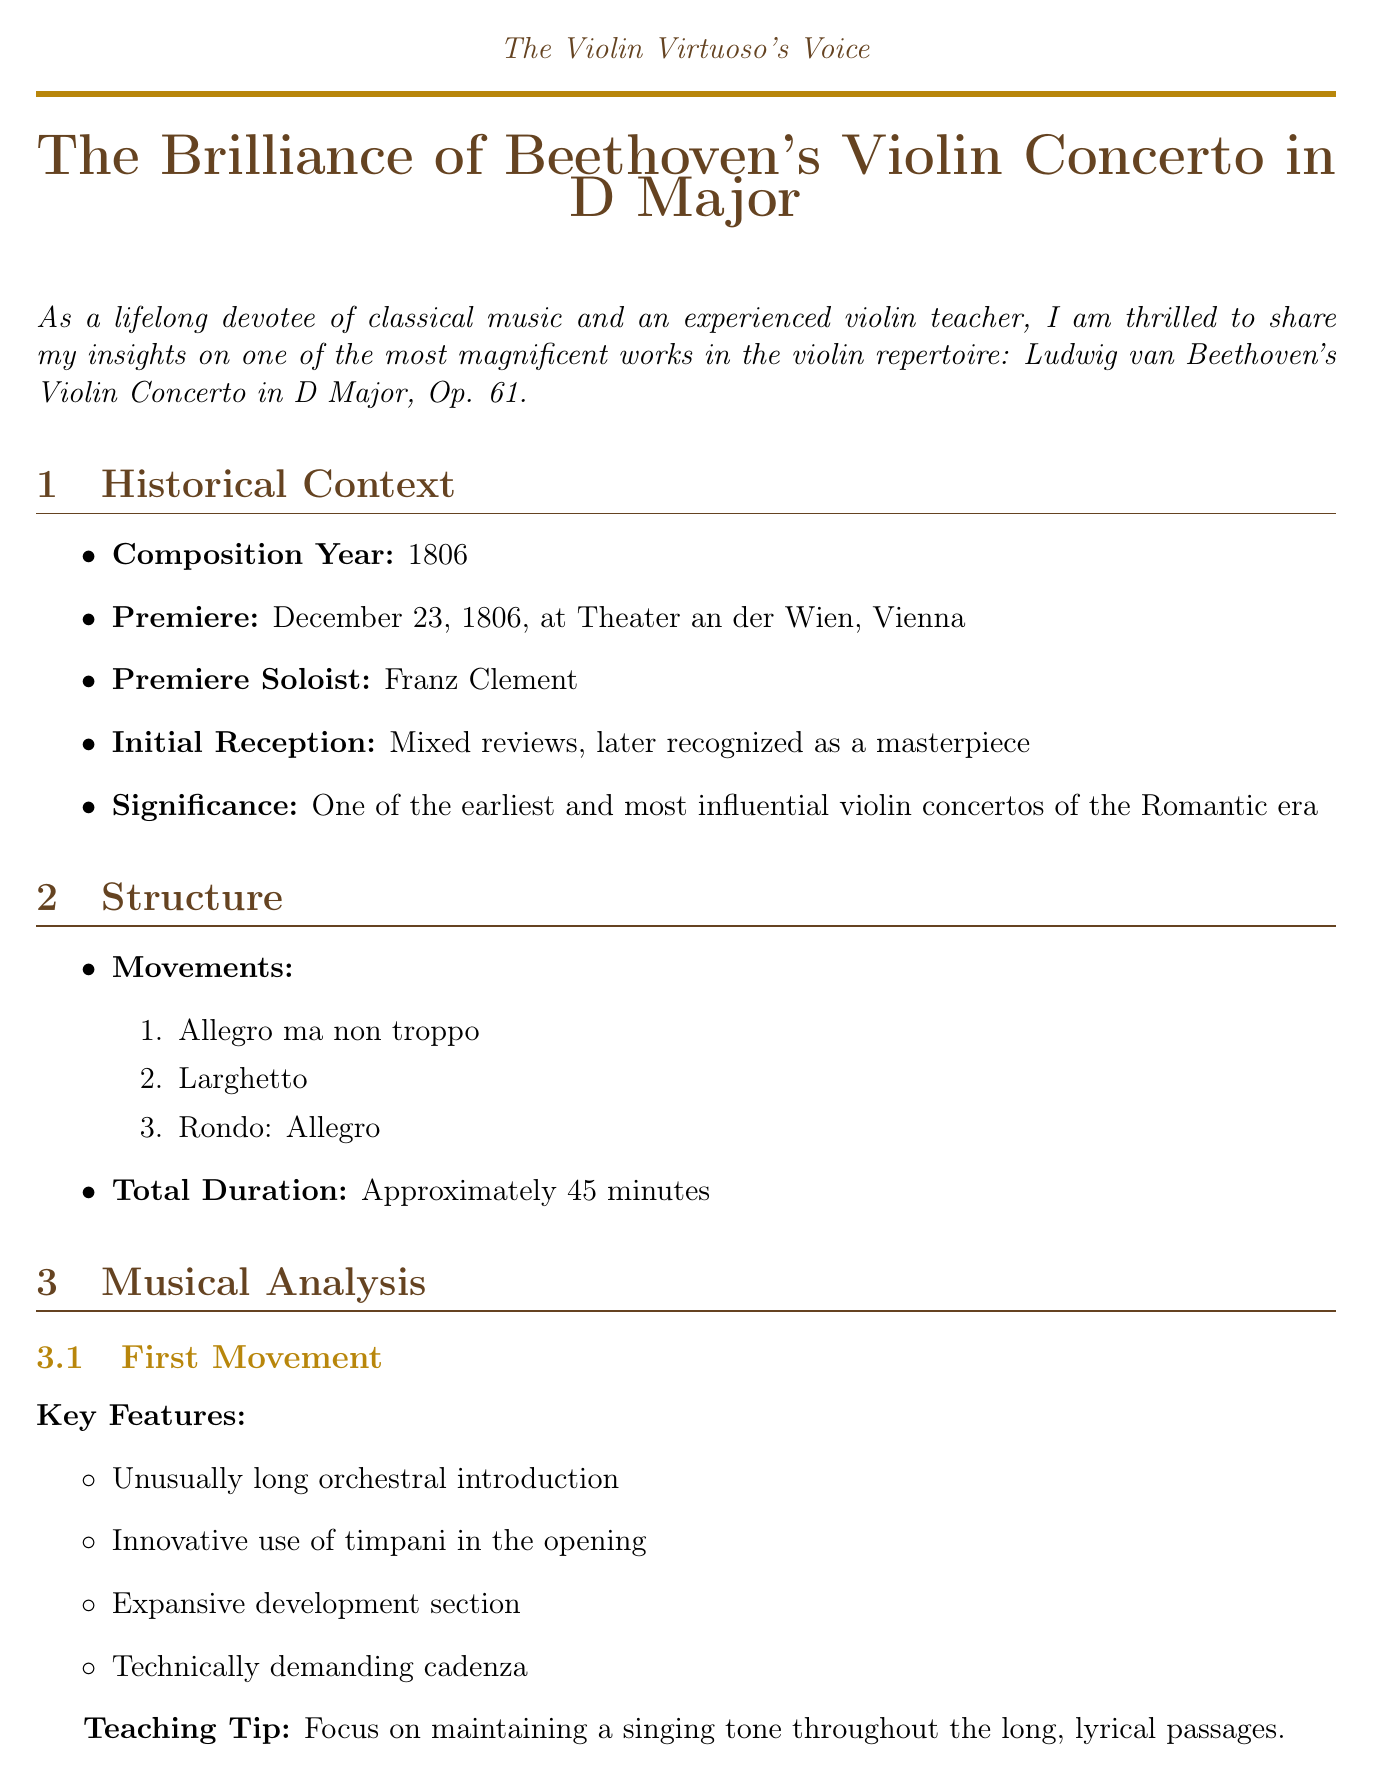What is the composition year of Beethoven's Violin Concerto? The composition year is stated in the historical context of the document.
Answer: 1806 Who was the premiere soloist of the concerto? The document indicates the name of the soloist at the premiere.
Answer: Franz Clement What is the total duration of the concerto? The total duration is mentioned in the structure section of the document.
Answer: Approximately 45 minutes What teaching tip is suggested for the first movement? The document provides a specific teaching tip for the first movement.
Answer: Focus on maintaining a singing tone throughout the long, lyrical passages What are the key features of the second movement? The key features listed in the musical analysis section highlight the characteristics of the second movement.
Answer: Serene and contemplative mood, seamless transition to the third movement What does the third movement's teaching tip emphasize? The document outlines the focus of the teaching tip for the third movement.
Answer: Work on crisp articulation and rhythmic precision in the faster passages Which famous violinist performed in 1940? The document lists notable performances, and this specifies the year.
Answer: Jascha Heifetz What is one of the performance challenges listed? The document discusses challenges faced by performers of the concerto.
Answer: Maintaining stamina throughout the lengthy work 